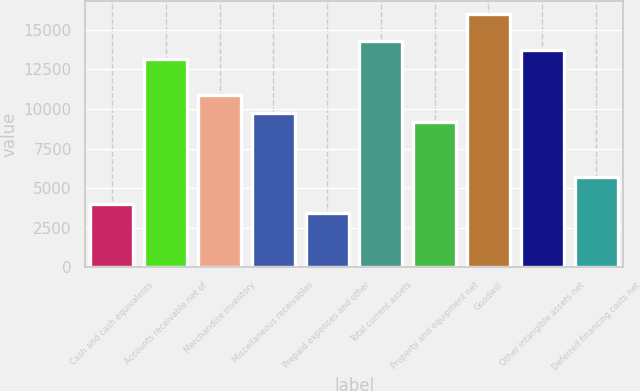Convert chart. <chart><loc_0><loc_0><loc_500><loc_500><bar_chart><fcel>Cash and cash equivalents<fcel>Accounts receivable net of<fcel>Merchandise inventory<fcel>Miscellaneous receivables<fcel>Prepaid expenses and other<fcel>Total current assets<fcel>Property and equipment net<fcel>Goodwill<fcel>Other intangible assets net<fcel>Deferred financing costs net<nl><fcel>4004.06<fcel>13155.7<fcel>10867.8<fcel>9723.86<fcel>3432.08<fcel>14299.7<fcel>9151.88<fcel>16015.6<fcel>13727.7<fcel>5720<nl></chart> 